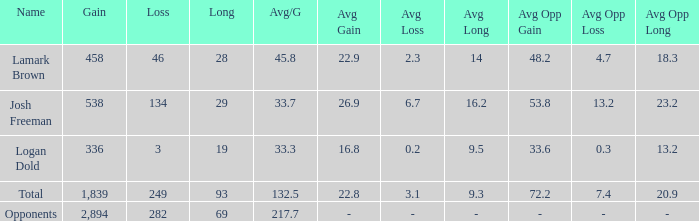Which Avg/G has a Gain of 1,839? 132.5. 